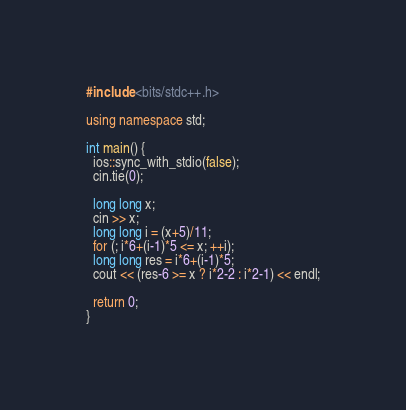Convert code to text. <code><loc_0><loc_0><loc_500><loc_500><_C++_>#include <bits/stdc++.h>

using namespace std;

int main() {
  ios::sync_with_stdio(false);
  cin.tie(0);

  long long x;
  cin >> x;
  long long i = (x+5)/11; 
  for (; i*6+(i-1)*5 <= x; ++i);
  long long res = i*6+(i-1)*5;
  cout << (res-6 >= x ? i*2-2 : i*2-1) << endl;

  return 0;
}

</code> 